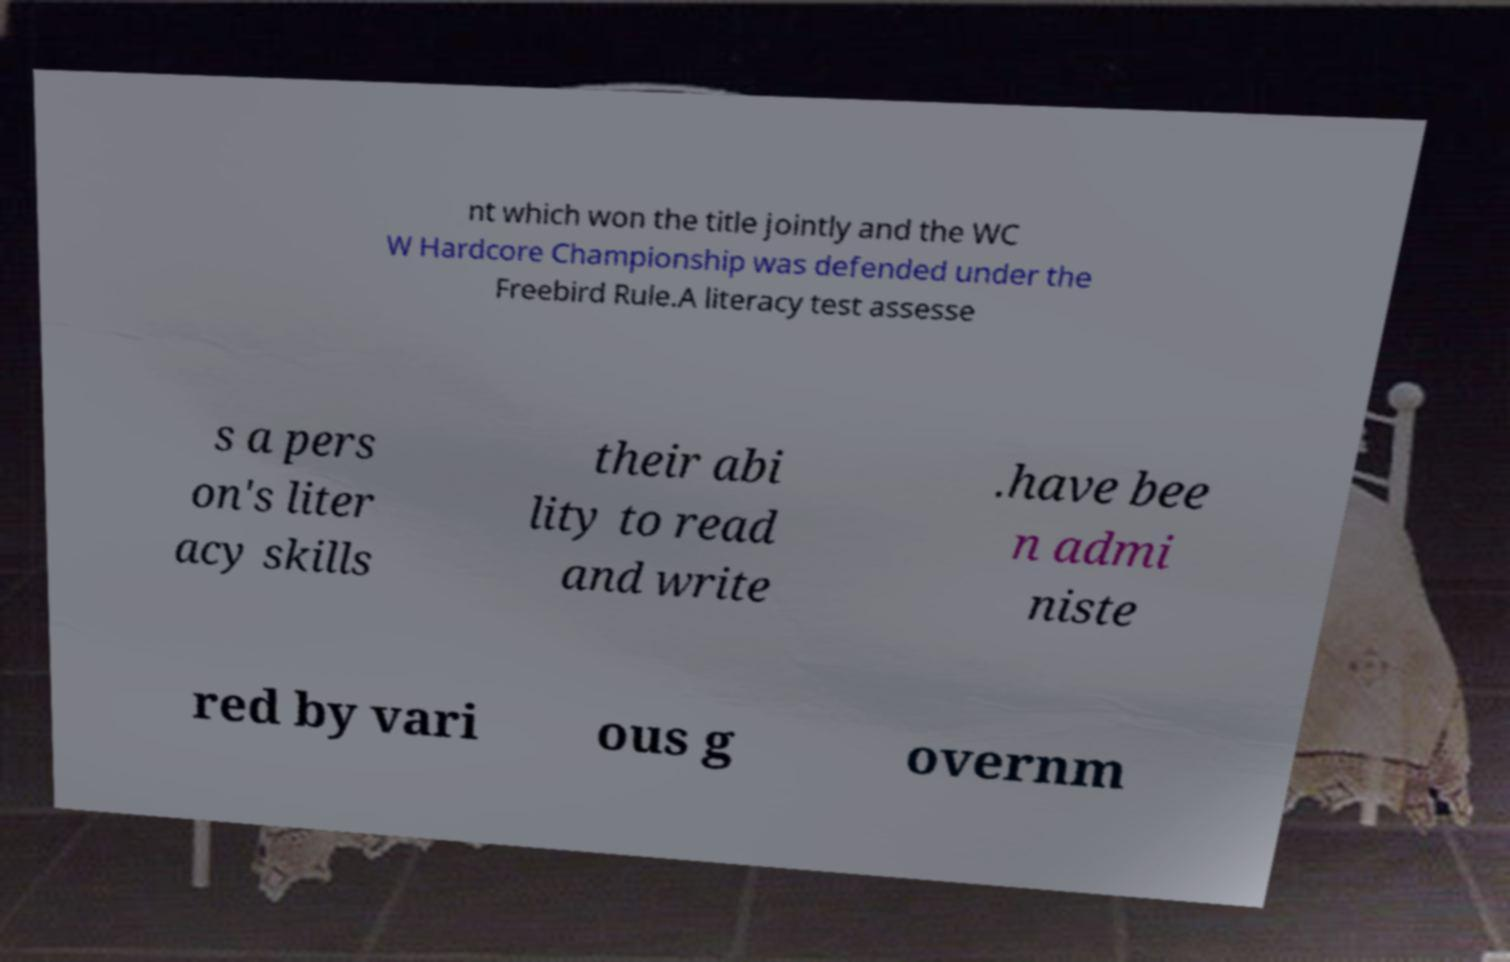Can you accurately transcribe the text from the provided image for me? nt which won the title jointly and the WC W Hardcore Championship was defended under the Freebird Rule.A literacy test assesse s a pers on's liter acy skills their abi lity to read and write .have bee n admi niste red by vari ous g overnm 